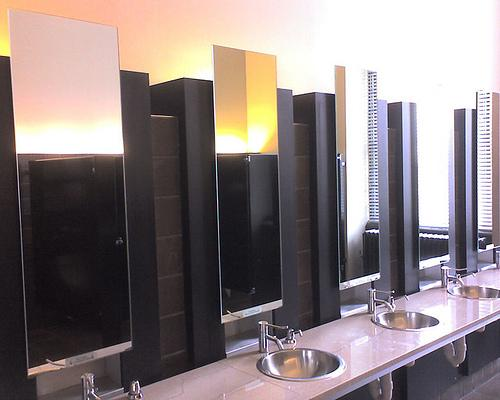What type of building is this bathroom likely to be in? Please explain your reasoning. business. The business building has a bathroom. 